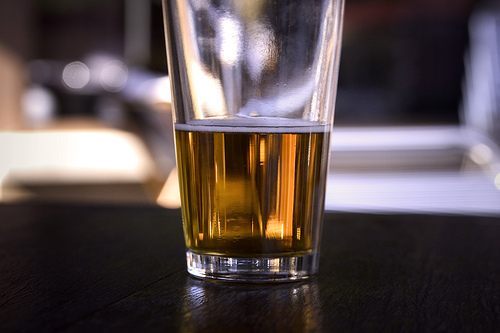<image>
Can you confirm if the beer is under the glass? No. The beer is not positioned under the glass. The vertical relationship between these objects is different. Is there a glass above the table? No. The glass is not positioned above the table. The vertical arrangement shows a different relationship. Where is the table in relation to the glass? Is it on the glass? No. The table is not positioned on the glass. They may be near each other, but the table is not supported by or resting on top of the glass. 